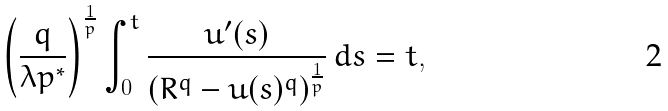Convert formula to latex. <formula><loc_0><loc_0><loc_500><loc_500>\left ( \frac { q } { \lambda p ^ { * } } \right ) ^ { \frac { 1 } { p } } \int _ { 0 } ^ { t } \frac { u ^ { \prime } ( s ) } { ( R ^ { q } - u ( s ) ^ { q } ) ^ { \frac { 1 } { p } } } \, d s = t ,</formula> 